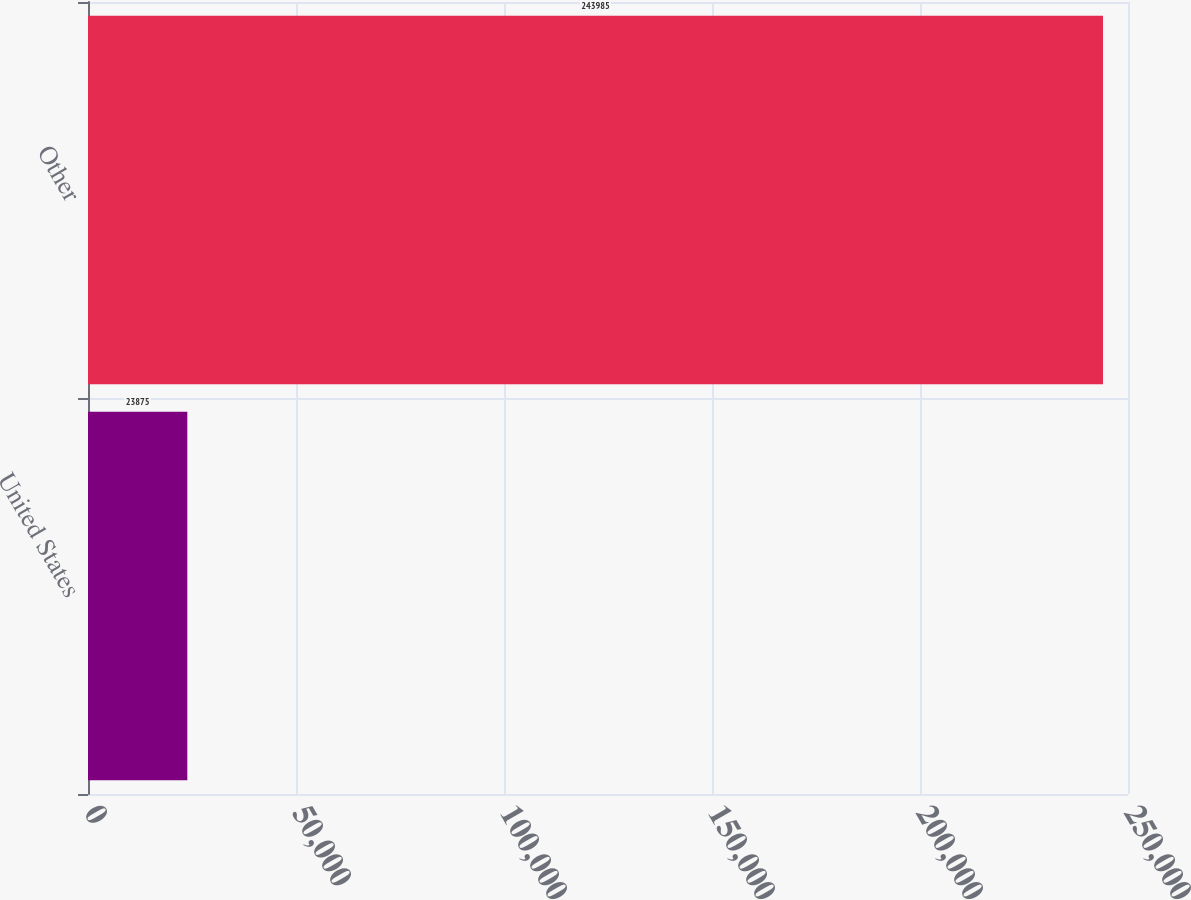Convert chart. <chart><loc_0><loc_0><loc_500><loc_500><bar_chart><fcel>United States<fcel>Other<nl><fcel>23875<fcel>243985<nl></chart> 